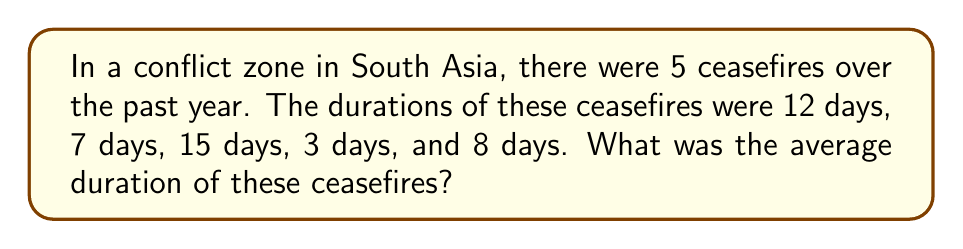Show me your answer to this math problem. To find the average duration of the ceasefires, we need to:

1. Sum up the total duration of all ceasefires
2. Divide the total by the number of ceasefires

Step 1: Calculate the total duration
$$ \text{Total duration} = 12 + 7 + 15 + 3 + 8 = 45 \text{ days} $$

Step 2: Count the number of ceasefires
$$ \text{Number of ceasefires} = 5 $$

Step 3: Calculate the average duration
$$ \text{Average duration} = \frac{\text{Total duration}}{\text{Number of ceasefires}} = \frac{45}{5} = 9 \text{ days} $$

Therefore, the average duration of the ceasefires was 9 days.
Answer: 9 days 